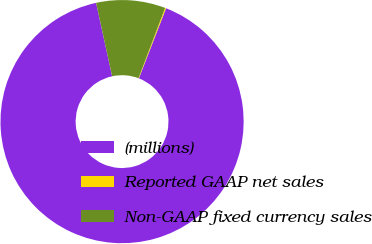<chart> <loc_0><loc_0><loc_500><loc_500><pie_chart><fcel>(millions)<fcel>Reported GAAP net sales<fcel>Non-GAAP fixed currency sales<nl><fcel>90.68%<fcel>0.13%<fcel>9.19%<nl></chart> 